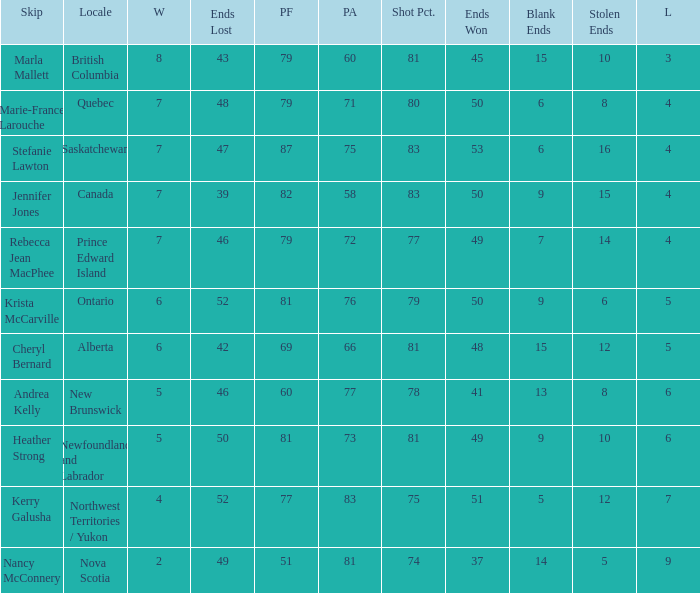What is the pf for Rebecca Jean Macphee? 79.0. 